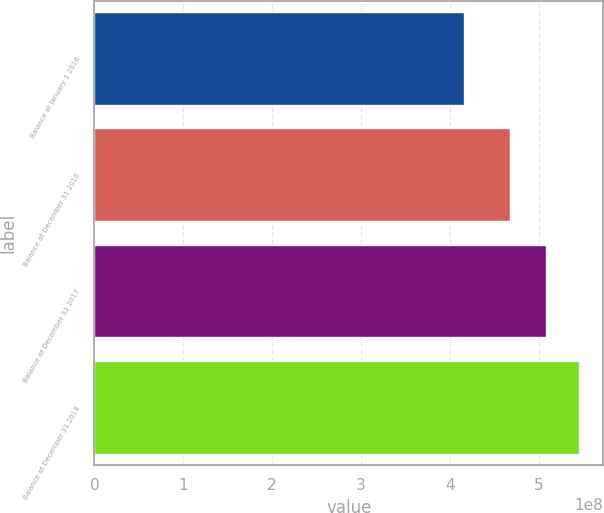Convert chart to OTSL. <chart><loc_0><loc_0><loc_500><loc_500><bar_chart><fcel>Balance at January 1 2016<fcel>Balance at December 31 2016<fcel>Balance at December 31 2017<fcel>Balance at December 31 2018<nl><fcel>4.16505e+08<fcel>4.68172e+08<fcel>5.08402e+08<fcel>5.45538e+08<nl></chart> 